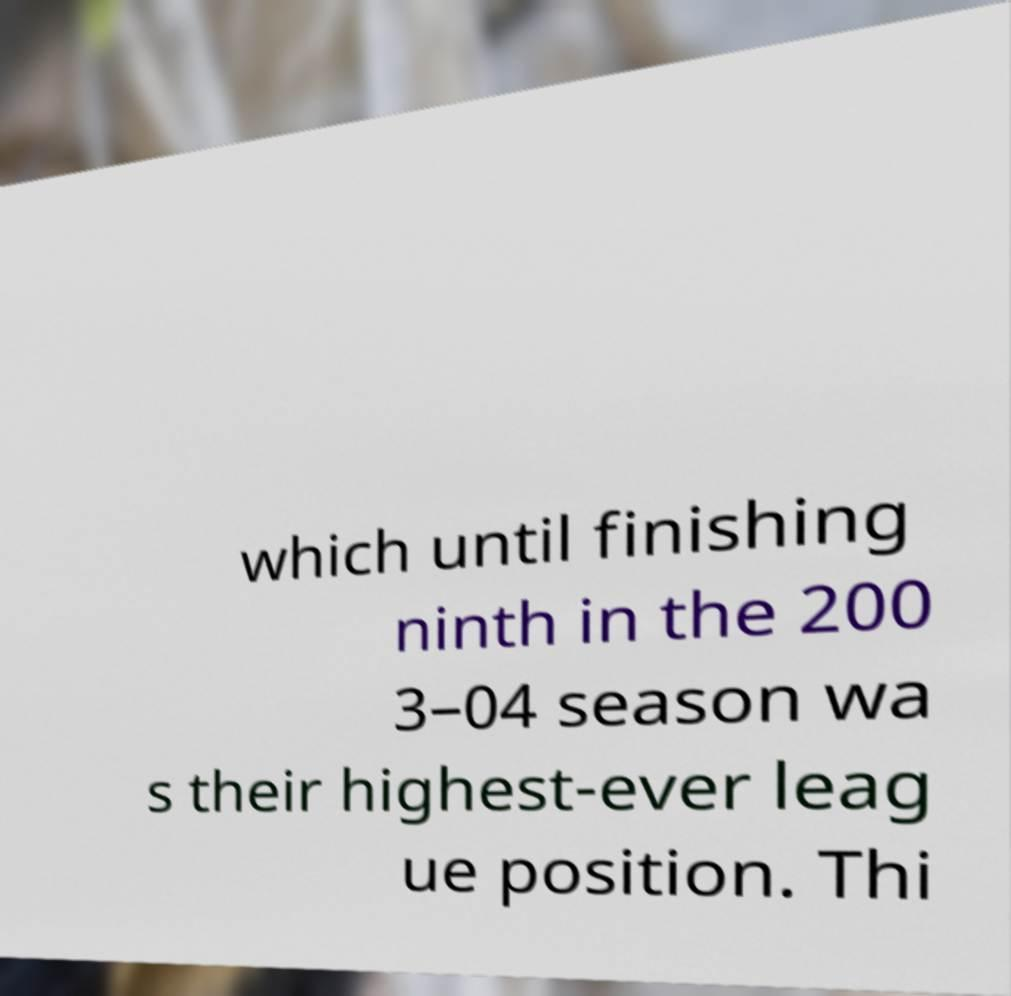Can you read and provide the text displayed in the image?This photo seems to have some interesting text. Can you extract and type it out for me? which until finishing ninth in the 200 3–04 season wa s their highest-ever leag ue position. Thi 